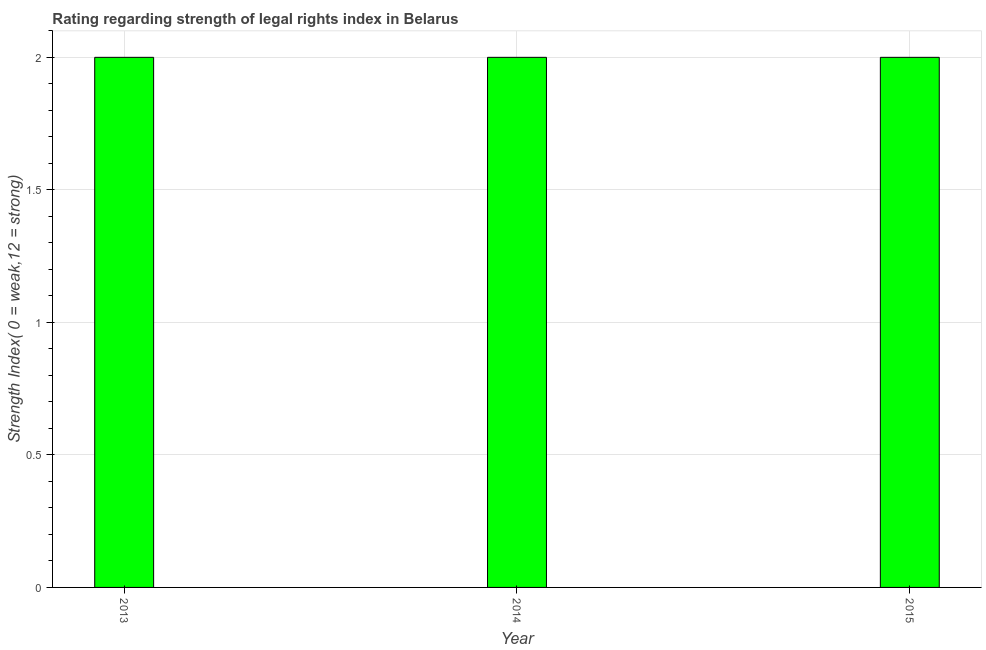Does the graph contain any zero values?
Your answer should be compact. No. What is the title of the graph?
Your answer should be very brief. Rating regarding strength of legal rights index in Belarus. What is the label or title of the X-axis?
Ensure brevity in your answer.  Year. What is the label or title of the Y-axis?
Your response must be concise. Strength Index( 0 = weak,12 = strong). What is the strength of legal rights index in 2015?
Provide a succinct answer. 2. Across all years, what is the maximum strength of legal rights index?
Provide a short and direct response. 2. In which year was the strength of legal rights index minimum?
Provide a succinct answer. 2013. What is the difference between the strength of legal rights index in 2014 and 2015?
Your answer should be compact. 0. What is the median strength of legal rights index?
Provide a short and direct response. 2. In how many years, is the strength of legal rights index greater than 0.1 ?
Give a very brief answer. 3. What is the ratio of the strength of legal rights index in 2013 to that in 2014?
Offer a terse response. 1. What is the difference between the highest and the lowest strength of legal rights index?
Offer a very short reply. 0. How many bars are there?
Ensure brevity in your answer.  3. Are all the bars in the graph horizontal?
Your answer should be very brief. No. How many years are there in the graph?
Make the answer very short. 3. What is the difference between two consecutive major ticks on the Y-axis?
Your answer should be compact. 0.5. Are the values on the major ticks of Y-axis written in scientific E-notation?
Make the answer very short. No. What is the Strength Index( 0 = weak,12 = strong) in 2013?
Make the answer very short. 2. What is the difference between the Strength Index( 0 = weak,12 = strong) in 2013 and 2014?
Keep it short and to the point. 0. What is the ratio of the Strength Index( 0 = weak,12 = strong) in 2013 to that in 2015?
Give a very brief answer. 1. What is the ratio of the Strength Index( 0 = weak,12 = strong) in 2014 to that in 2015?
Offer a terse response. 1. 